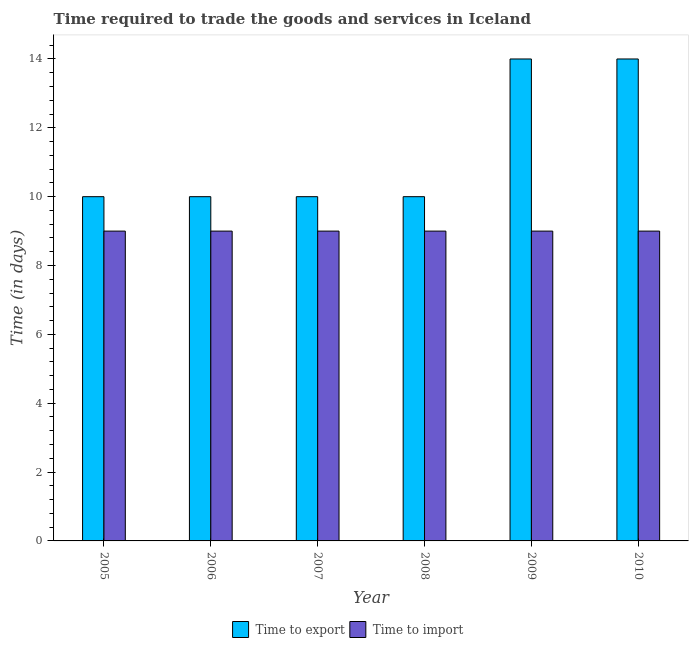How many different coloured bars are there?
Provide a short and direct response. 2. How many bars are there on the 1st tick from the left?
Give a very brief answer. 2. How many bars are there on the 5th tick from the right?
Provide a short and direct response. 2. What is the label of the 4th group of bars from the left?
Provide a succinct answer. 2008. What is the time to export in 2006?
Keep it short and to the point. 10. Across all years, what is the maximum time to import?
Your response must be concise. 9. Across all years, what is the minimum time to export?
Provide a succinct answer. 10. What is the total time to import in the graph?
Give a very brief answer. 54. What is the difference between the time to import in 2006 and the time to export in 2008?
Ensure brevity in your answer.  0. What is the average time to export per year?
Make the answer very short. 11.33. In how many years, is the time to import greater than 11.6 days?
Your response must be concise. 0. Is the time to import in 2008 less than that in 2010?
Make the answer very short. No. Is the difference between the time to export in 2005 and 2008 greater than the difference between the time to import in 2005 and 2008?
Offer a terse response. No. What is the difference between the highest and the lowest time to import?
Give a very brief answer. 0. Is the sum of the time to export in 2008 and 2009 greater than the maximum time to import across all years?
Your response must be concise. Yes. What does the 1st bar from the left in 2005 represents?
Ensure brevity in your answer.  Time to export. What does the 1st bar from the right in 2006 represents?
Offer a terse response. Time to import. Are all the bars in the graph horizontal?
Keep it short and to the point. No. How many years are there in the graph?
Provide a short and direct response. 6. What is the difference between two consecutive major ticks on the Y-axis?
Ensure brevity in your answer.  2. Does the graph contain any zero values?
Make the answer very short. No. How many legend labels are there?
Give a very brief answer. 2. How are the legend labels stacked?
Provide a succinct answer. Horizontal. What is the title of the graph?
Make the answer very short. Time required to trade the goods and services in Iceland. What is the label or title of the Y-axis?
Keep it short and to the point. Time (in days). What is the Time (in days) in Time to export in 2005?
Keep it short and to the point. 10. What is the Time (in days) of Time to import in 2005?
Offer a terse response. 9. What is the Time (in days) of Time to import in 2006?
Offer a terse response. 9. What is the Time (in days) in Time to export in 2009?
Your answer should be compact. 14. What is the Time (in days) in Time to import in 2009?
Offer a very short reply. 9. Across all years, what is the maximum Time (in days) of Time to export?
Keep it short and to the point. 14. Across all years, what is the minimum Time (in days) of Time to export?
Provide a succinct answer. 10. Across all years, what is the minimum Time (in days) of Time to import?
Give a very brief answer. 9. What is the difference between the Time (in days) of Time to import in 2005 and that in 2006?
Your answer should be compact. 0. What is the difference between the Time (in days) in Time to export in 2005 and that in 2007?
Your response must be concise. 0. What is the difference between the Time (in days) of Time to import in 2005 and that in 2007?
Make the answer very short. 0. What is the difference between the Time (in days) in Time to export in 2005 and that in 2008?
Offer a terse response. 0. What is the difference between the Time (in days) in Time to import in 2005 and that in 2008?
Ensure brevity in your answer.  0. What is the difference between the Time (in days) in Time to import in 2005 and that in 2010?
Your answer should be very brief. 0. What is the difference between the Time (in days) in Time to export in 2006 and that in 2007?
Your response must be concise. 0. What is the difference between the Time (in days) in Time to import in 2006 and that in 2007?
Your answer should be very brief. 0. What is the difference between the Time (in days) in Time to import in 2006 and that in 2008?
Your answer should be very brief. 0. What is the difference between the Time (in days) in Time to import in 2006 and that in 2010?
Offer a terse response. 0. What is the difference between the Time (in days) of Time to import in 2008 and that in 2009?
Keep it short and to the point. 0. What is the difference between the Time (in days) of Time to export in 2008 and that in 2010?
Offer a very short reply. -4. What is the difference between the Time (in days) in Time to import in 2008 and that in 2010?
Your response must be concise. 0. What is the difference between the Time (in days) in Time to import in 2009 and that in 2010?
Give a very brief answer. 0. What is the difference between the Time (in days) in Time to export in 2005 and the Time (in days) in Time to import in 2006?
Make the answer very short. 1. What is the difference between the Time (in days) of Time to export in 2005 and the Time (in days) of Time to import in 2008?
Ensure brevity in your answer.  1. What is the difference between the Time (in days) of Time to export in 2005 and the Time (in days) of Time to import in 2009?
Offer a very short reply. 1. What is the difference between the Time (in days) in Time to export in 2006 and the Time (in days) in Time to import in 2008?
Offer a terse response. 1. What is the difference between the Time (in days) in Time to export in 2007 and the Time (in days) in Time to import in 2009?
Your answer should be very brief. 1. What is the difference between the Time (in days) in Time to export in 2008 and the Time (in days) in Time to import in 2009?
Offer a terse response. 1. What is the difference between the Time (in days) in Time to export in 2008 and the Time (in days) in Time to import in 2010?
Offer a terse response. 1. What is the difference between the Time (in days) of Time to export in 2009 and the Time (in days) of Time to import in 2010?
Ensure brevity in your answer.  5. What is the average Time (in days) of Time to export per year?
Ensure brevity in your answer.  11.33. What is the average Time (in days) in Time to import per year?
Offer a terse response. 9. In the year 2006, what is the difference between the Time (in days) of Time to export and Time (in days) of Time to import?
Offer a very short reply. 1. In the year 2010, what is the difference between the Time (in days) in Time to export and Time (in days) in Time to import?
Your answer should be very brief. 5. What is the ratio of the Time (in days) of Time to export in 2005 to that in 2006?
Your answer should be compact. 1. What is the ratio of the Time (in days) in Time to import in 2005 to that in 2007?
Offer a very short reply. 1. What is the ratio of the Time (in days) of Time to export in 2005 to that in 2008?
Make the answer very short. 1. What is the ratio of the Time (in days) in Time to import in 2005 to that in 2009?
Offer a terse response. 1. What is the ratio of the Time (in days) in Time to export in 2005 to that in 2010?
Keep it short and to the point. 0.71. What is the ratio of the Time (in days) of Time to export in 2006 to that in 2010?
Your response must be concise. 0.71. What is the ratio of the Time (in days) of Time to export in 2007 to that in 2009?
Give a very brief answer. 0.71. What is the ratio of the Time (in days) in Time to import in 2007 to that in 2009?
Provide a succinct answer. 1. What is the ratio of the Time (in days) in Time to export in 2007 to that in 2010?
Ensure brevity in your answer.  0.71. What is the ratio of the Time (in days) in Time to import in 2007 to that in 2010?
Offer a terse response. 1. What is the ratio of the Time (in days) in Time to import in 2008 to that in 2009?
Ensure brevity in your answer.  1. What is the ratio of the Time (in days) of Time to export in 2009 to that in 2010?
Your answer should be compact. 1. What is the ratio of the Time (in days) in Time to import in 2009 to that in 2010?
Provide a succinct answer. 1. 